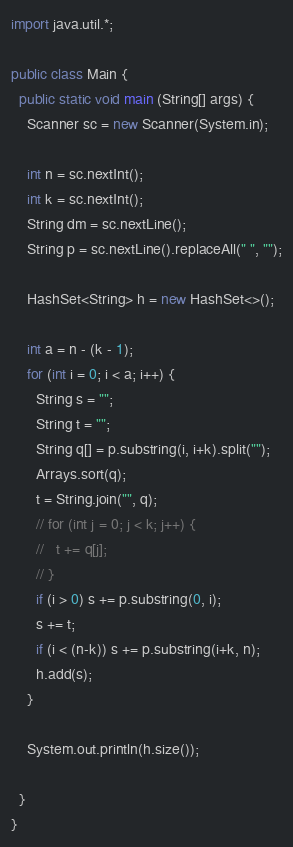Convert code to text. <code><loc_0><loc_0><loc_500><loc_500><_Java_>import java.util.*;

public class Main {
  public static void main (String[] args) {
    Scanner sc = new Scanner(System.in);

    int n = sc.nextInt();
    int k = sc.nextInt();
    String dm = sc.nextLine();
    String p = sc.nextLine().replaceAll(" ", "");

    HashSet<String> h = new HashSet<>();

    int a = n - (k - 1);
    for (int i = 0; i < a; i++) {
      String s = "";
      String t = "";
      String q[] = p.substring(i, i+k).split("");
      Arrays.sort(q);
      t = String.join("", q);
      // for (int j = 0; j < k; j++) {
      //   t += q[j];
      // }
      if (i > 0) s += p.substring(0, i);
      s += t;
      if (i < (n-k)) s += p.substring(i+k, n);
      h.add(s);
    }

    System.out.println(h.size());

  }
}</code> 